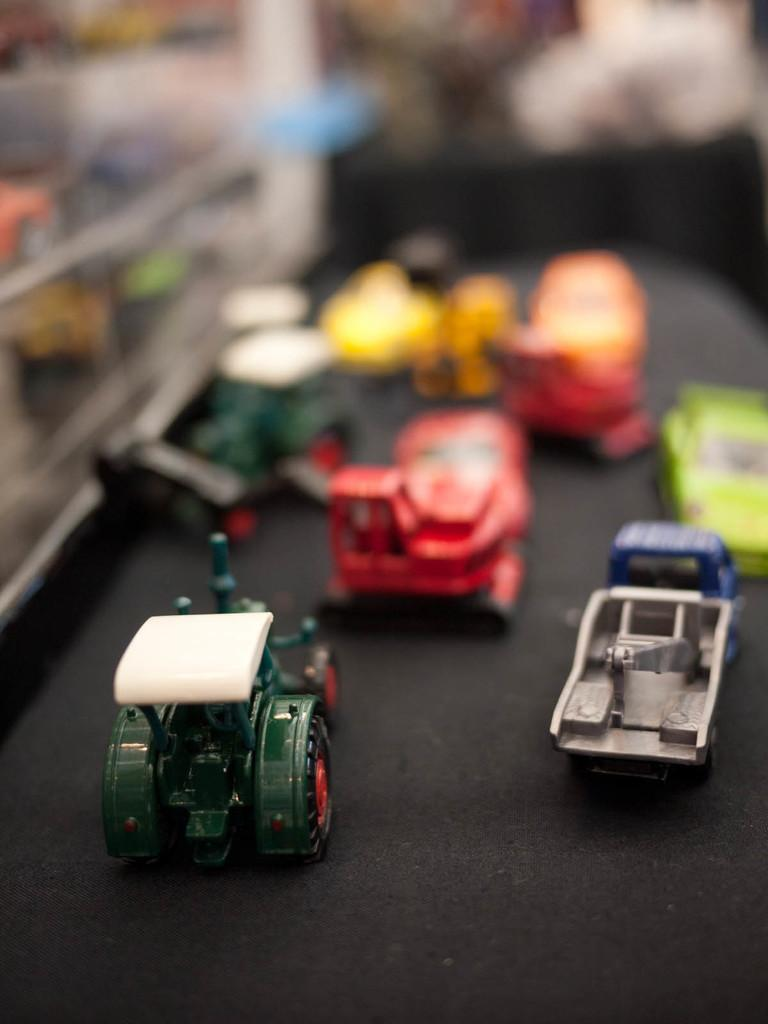What objects are present in the image? There are toys in the image. What is the color of the surface on which the toys are placed? The toys are on a black surface. Can you describe the background of the image? The background of the image is blurred. What type of pan can be seen in the image? There is no pan present in the image. How many jars are visible in the image? There are no jars present in the image. 